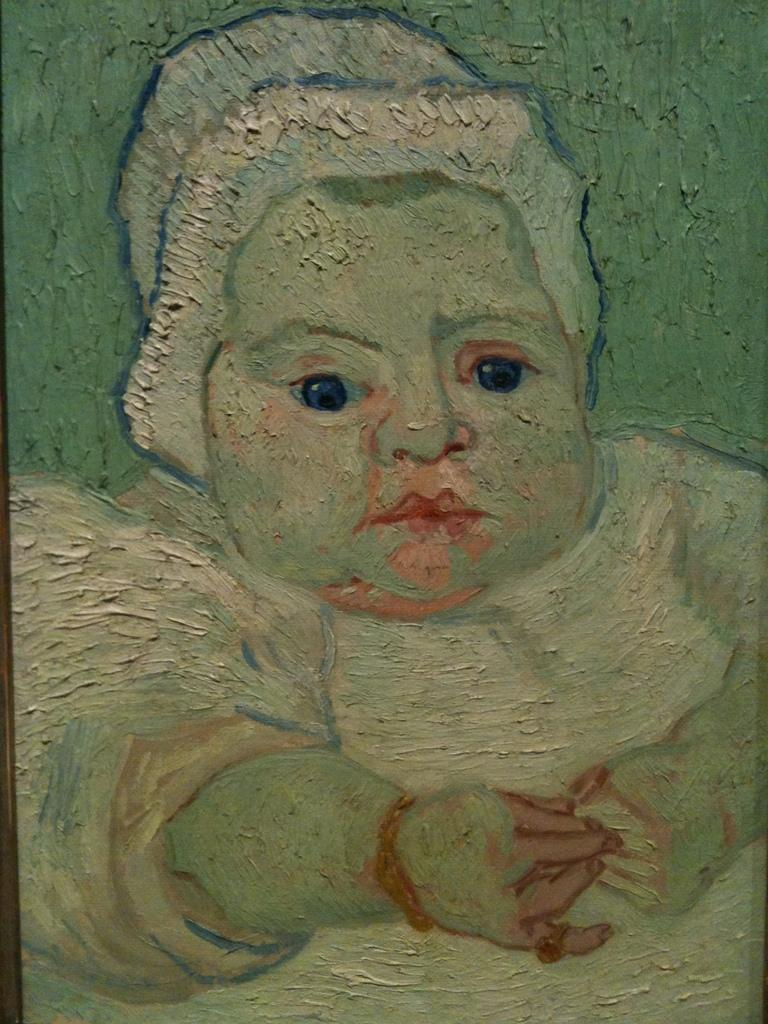What is depicted in the image? There is a painting of a kid in the image. Can you describe the background of the painting? The background of the painting is green. What type of prison can be seen in the background of the painting? There is no prison present in the image; it is a painting of a kid with a green background. What is being observed in the painting? The painting itself is not an observation, but rather a depiction of a kid with a green background. 